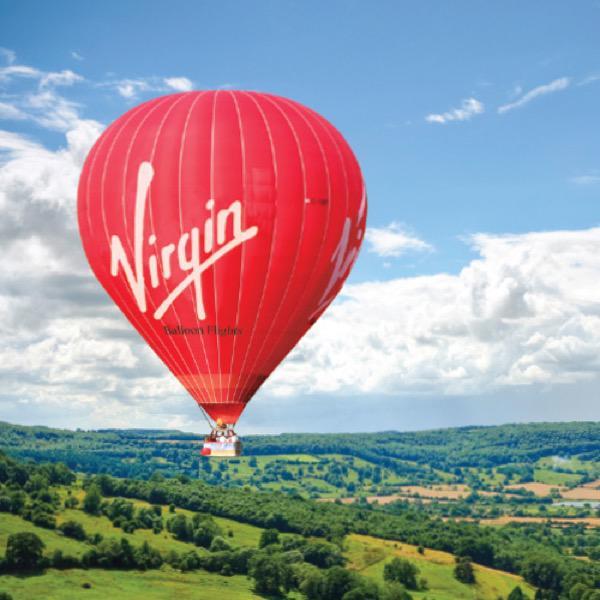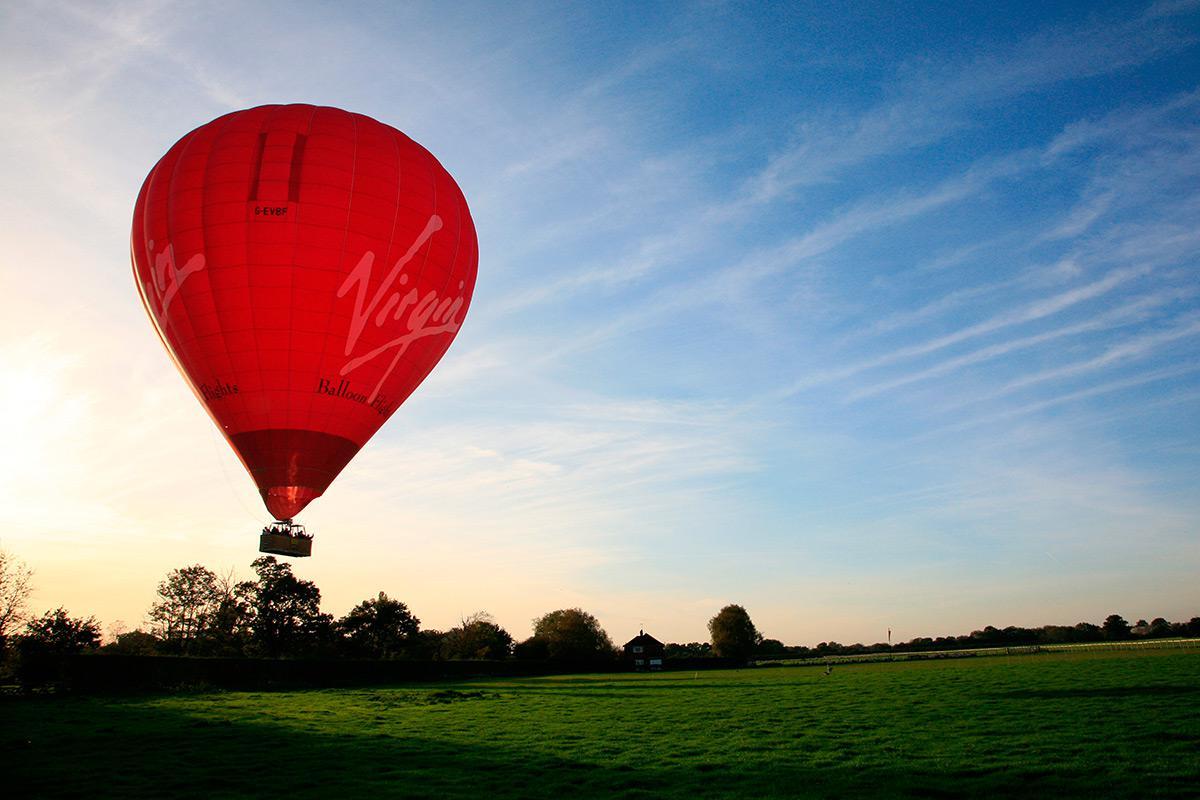The first image is the image on the left, the second image is the image on the right. Evaluate the accuracy of this statement regarding the images: "There are only two balloons and they are both upright.". Is it true? Answer yes or no. Yes. 